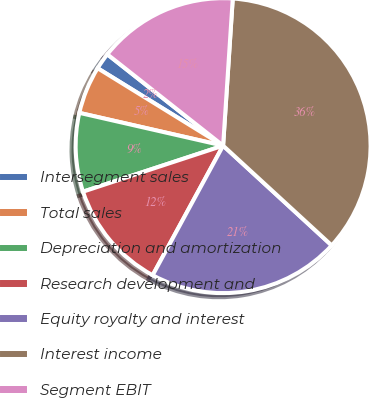Convert chart to OTSL. <chart><loc_0><loc_0><loc_500><loc_500><pie_chart><fcel>Intersegment sales<fcel>Total sales<fcel>Depreciation and amortization<fcel>Research development and<fcel>Equity royalty and interest<fcel>Interest income<fcel>Segment EBIT<nl><fcel>1.83%<fcel>5.23%<fcel>8.62%<fcel>12.02%<fcel>21.1%<fcel>35.78%<fcel>15.41%<nl></chart> 